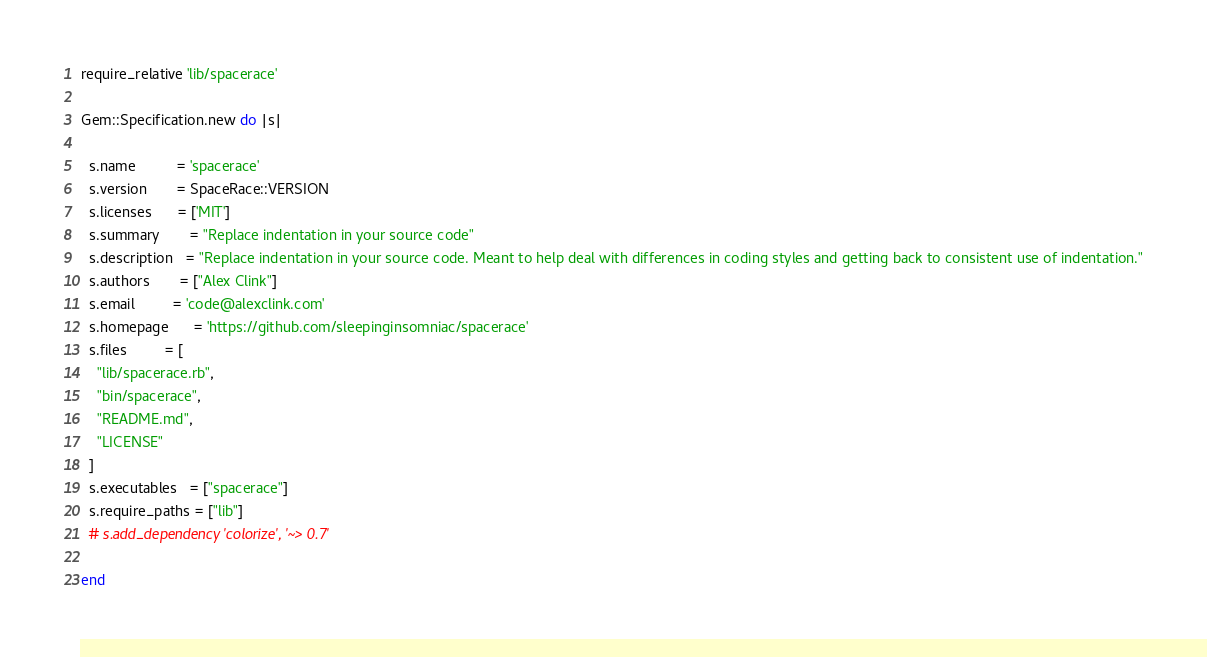Convert code to text. <code><loc_0><loc_0><loc_500><loc_500><_Ruby_>require_relative 'lib/spacerace'

Gem::Specification.new do |s|
  
  s.name          = 'spacerace'
  s.version       = SpaceRace::VERSION
  s.licenses      = ['MIT']
  s.summary       = "Replace indentation in your source code"
  s.description   = "Replace indentation in your source code. Meant to help deal with differences in coding styles and getting back to consistent use of indentation."
  s.authors       = ["Alex Clink"]
  s.email         = 'code@alexclink.com'
  s.homepage      = 'https://github.com/sleepinginsomniac/spacerace'
  s.files         = [
    "lib/spacerace.rb",
    "bin/spacerace",
    "README.md",
    "LICENSE"
  ]
  s.executables   = ["spacerace"]
  s.require_paths = ["lib"]
  # s.add_dependency 'colorize', '~> 0.7'
  
end
</code> 